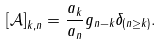Convert formula to latex. <formula><loc_0><loc_0><loc_500><loc_500>\left [ \mathcal { A } \right ] _ { k , n } = \frac { a _ { k } } { a _ { n } } g _ { n - k } \delta _ { \left ( n \geq k \right ) } .</formula> 